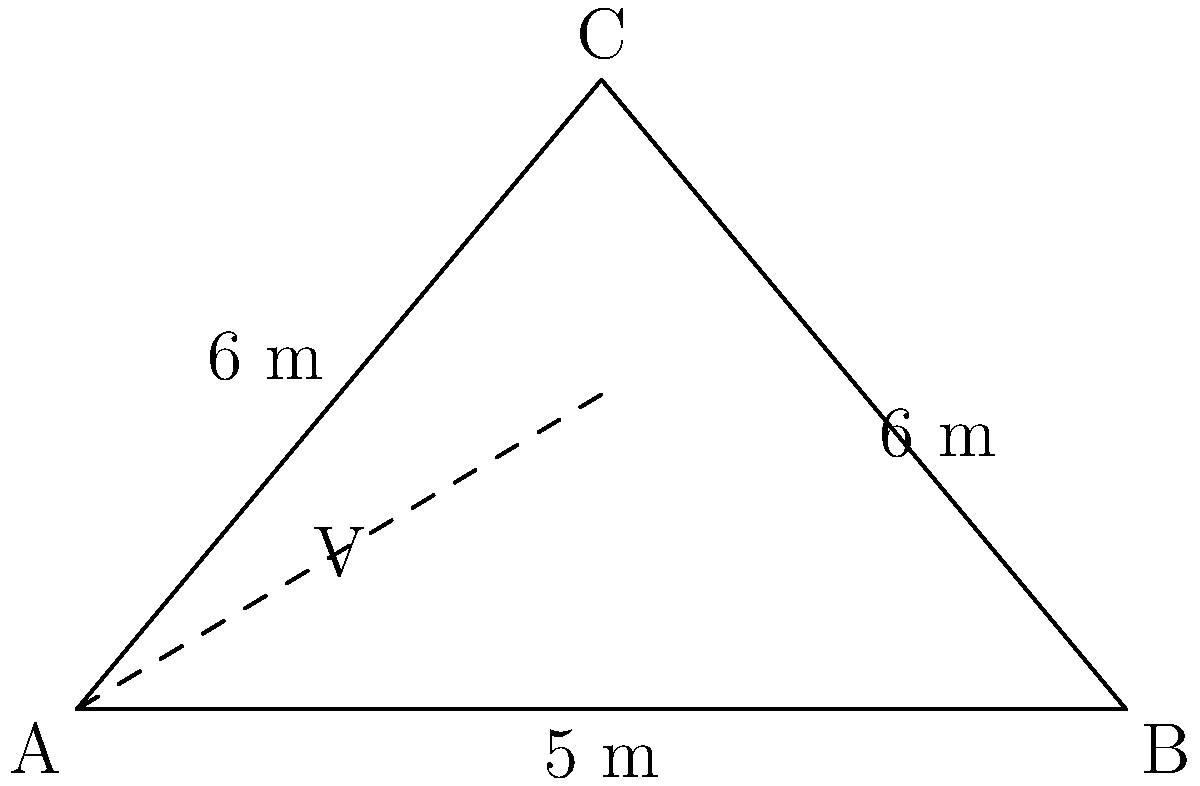You're standing at the crease, eyeing the "V" region between mid-off and mid-on. The pitch forms an isosceles triangle ABC, where AB is the crease (5 m wide), and the apex C is 6 m from both A and B. Calculate the area of the "V" region, which is half of this triangular field. How many square meters of prime hitting zone do you have to dominate? Let's approach this step-by-step:

1) First, we need to find the height of the triangle. We can do this using the Pythagorean theorem.

2) Let's call the height h. Half of the base is 2.5 m (since AB = 5 m).

3) Using the Pythagorean theorem:
   $$h^2 + 2.5^2 = 6^2$$

4) Solving for h:
   $$h^2 = 6^2 - 2.5^2 = 36 - 6.25 = 29.75$$
   $$h = \sqrt{29.75} \approx 5.45 \text{ m}$$

5) Now we can calculate the area of the whole triangle:
   $$\text{Area} = \frac{1}{2} \times \text{base} \times \text{height}$$
   $$\text{Area} = \frac{1}{2} \times 5 \times 5.45 = 13.625 \text{ m}^2$$

6) The "V" region is half of this area:
   $$\text{Area of "V"} = \frac{13.625}{2} = 6.8125 \text{ m}^2$$

Therefore, the area of the "V" region is approximately 6.8125 square meters.
Answer: 6.8125 m² 